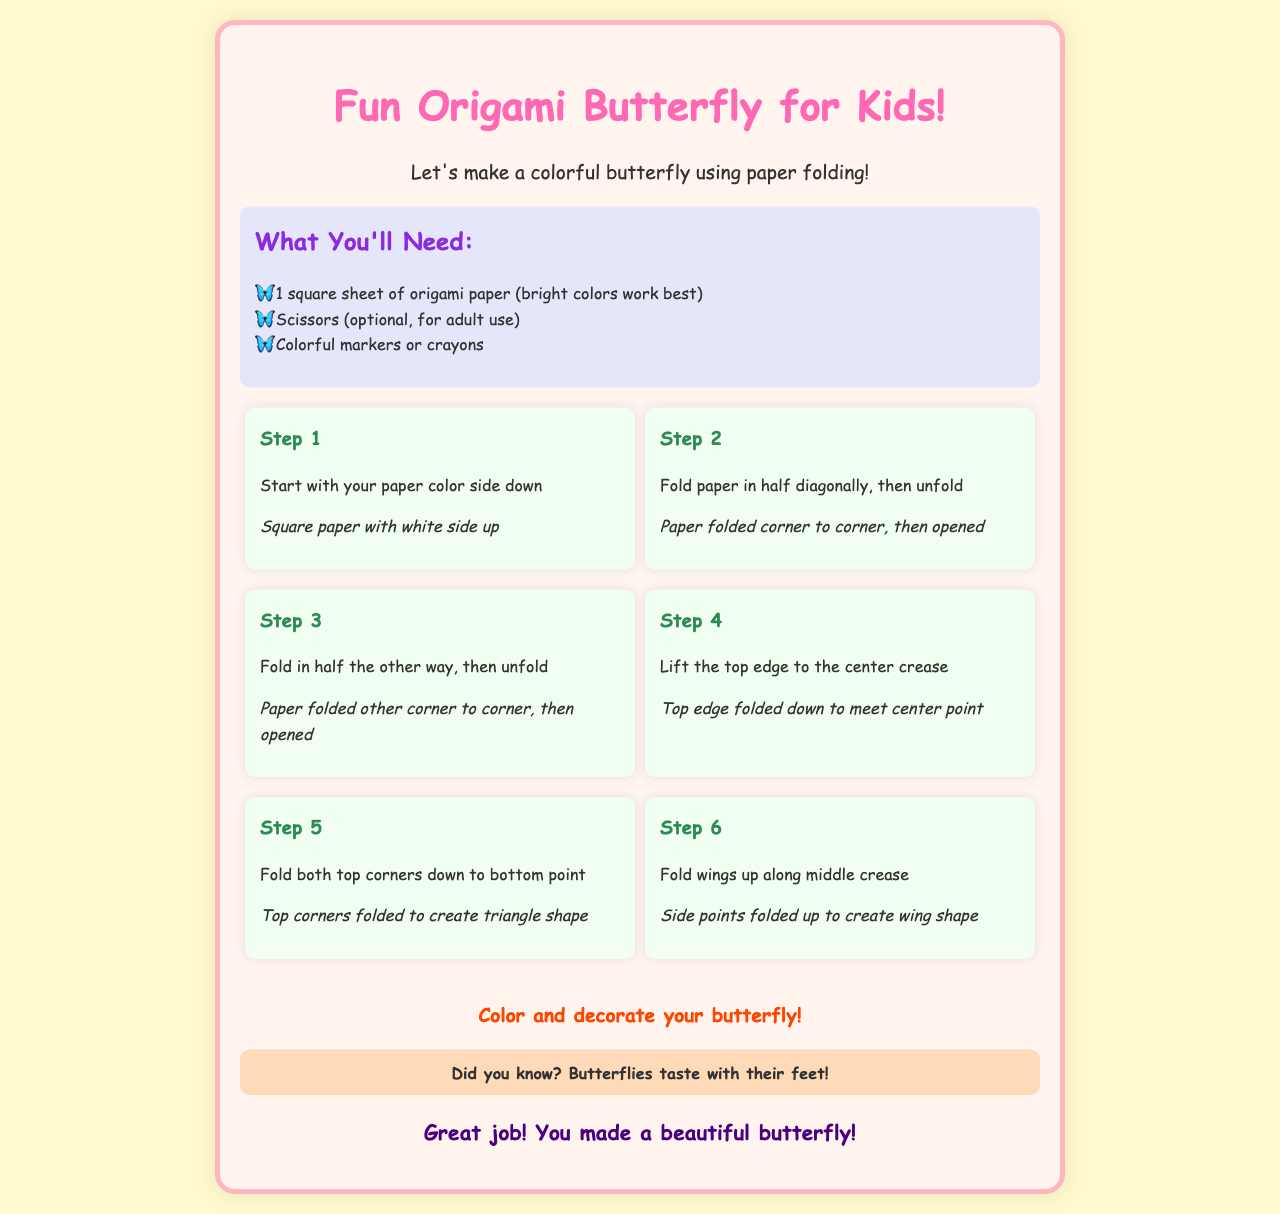What is the title of the project? The title clearly states that this is an origami project for kids involving a butterfly.
Answer: Fun Origami Butterfly for Kids! What do you need to make the origami butterfly? The document lists the supplies required to create the butterfly.
Answer: 1 square sheet of origami paper How many steps are there in making the butterfly? By counting the numbered steps provided in the document, the total steps can be determined.
Answer: 6 What color side should the paper start with facing down? The instructions specify the orientation of the paper before starting the origami project.
Answer: color side What should you fold the top edge to? The document details that the top edge should meet a specific point during the folding process.
Answer: center crease What fun fact is shared about butterflies? An interesting fact about butterflies is mentioned in the document.
Answer: Butterflies taste with their feet! What is the final step in the origami project? The document concludes with the last activity after completing the origami steps.
Answer: Color and decorate your butterfly! What is the background color of the document? The overall background color of the document is part of its design.
Answer: light yellow 